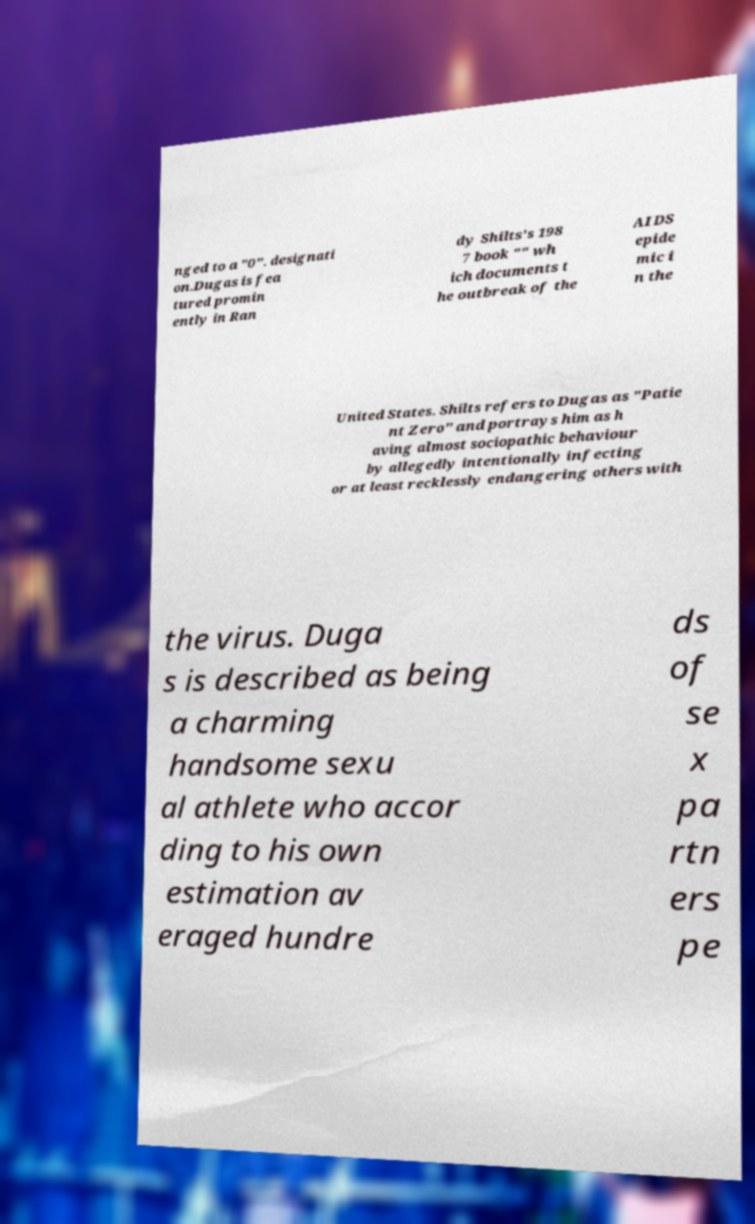For documentation purposes, I need the text within this image transcribed. Could you provide that? nged to a "0". designati on.Dugas is fea tured promin ently in Ran dy Shilts's 198 7 book "" wh ich documents t he outbreak of the AIDS epide mic i n the United States. Shilts refers to Dugas as "Patie nt Zero" and portrays him as h aving almost sociopathic behaviour by allegedly intentionally infecting or at least recklessly endangering others with the virus. Duga s is described as being a charming handsome sexu al athlete who accor ding to his own estimation av eraged hundre ds of se x pa rtn ers pe 